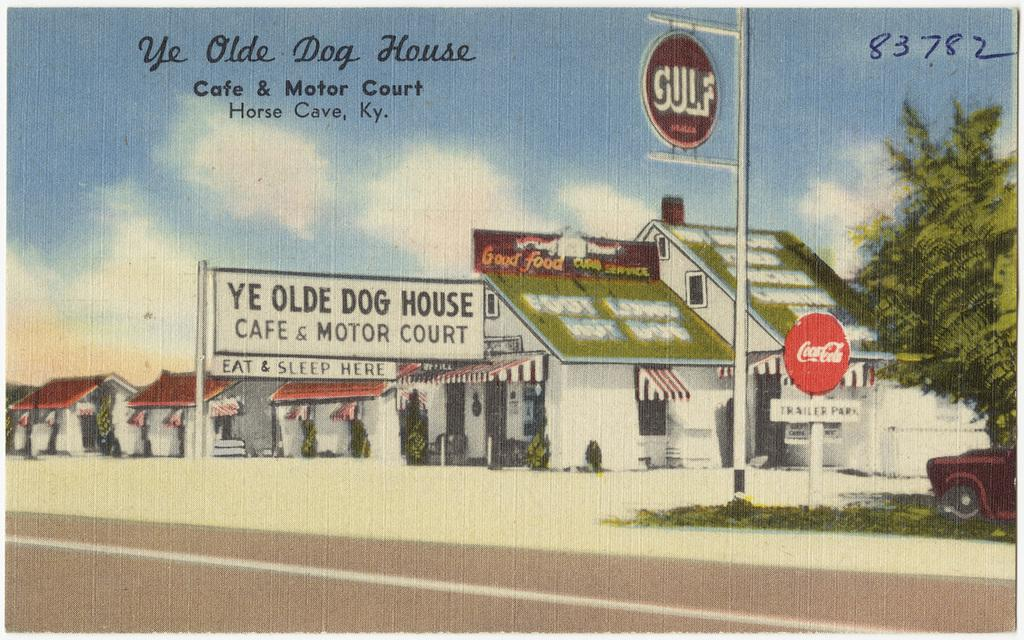<image>
Create a compact narrative representing the image presented. A drawing of Ye Olde Dog House store front. 